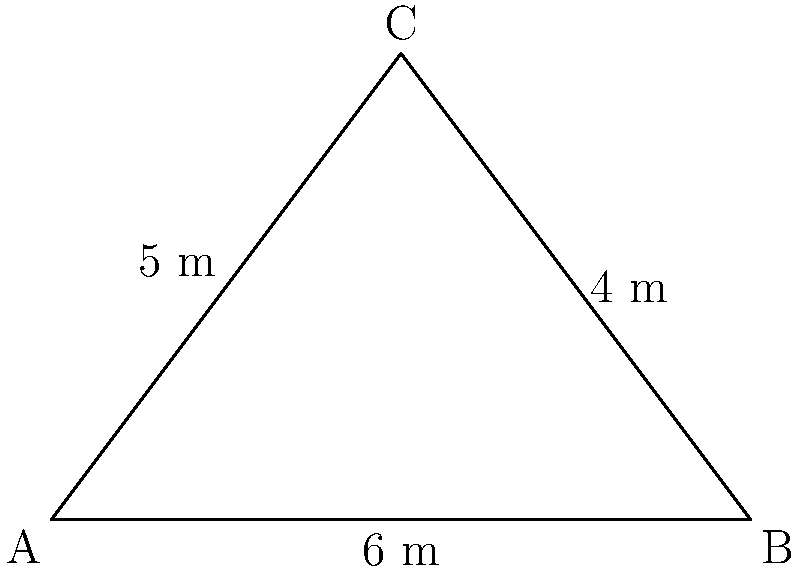The People's National Movement (PNM) is proposing a new triangular community center. The site has dimensions as shown in the diagram. Calculate the area of the proposed community center using the cross product method. Round your answer to the nearest square meter. To calculate the area using the cross product method, we'll follow these steps:

1) First, we need to represent two sides of the triangle as vectors. Let's choose $\vec{AB}$ and $\vec{AC}$.

   $\vec{AB} = (6,0)$
   $\vec{AC} = (3,4)$

2) The area of the parallelogram formed by these vectors is given by the magnitude of their cross product:

   Area = $|\vec{AB} \times \vec{AC}|$

3) For 2D vectors $(x_1, y_1)$ and $(x_2, y_2)$, the cross product is defined as:

   $(x_1, y_1) \times (x_2, y_2) = x_1y_2 - x_2y_1$

4) Applying this to our vectors:

   $(6,0) \times (3,4) = 6(4) - 3(0) = 24 - 0 = 24$

5) The magnitude of this cross product (24) gives us the area of the parallelogram.

6) Since we want the area of the triangle, which is half of the parallelogram, we divide by 2:

   Triangle Area = $\frac{24}{2} = 12$ square meters

Therefore, the area of the proposed PNM community center is 12 square meters.
Answer: 12 m² 